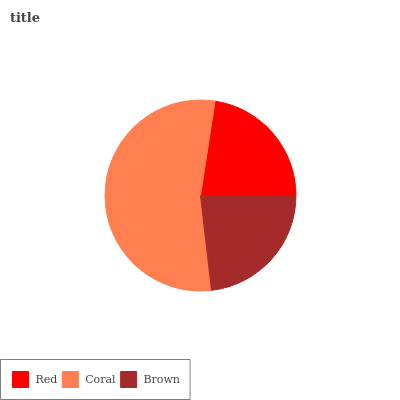Is Red the minimum?
Answer yes or no. Yes. Is Coral the maximum?
Answer yes or no. Yes. Is Brown the minimum?
Answer yes or no. No. Is Brown the maximum?
Answer yes or no. No. Is Coral greater than Brown?
Answer yes or no. Yes. Is Brown less than Coral?
Answer yes or no. Yes. Is Brown greater than Coral?
Answer yes or no. No. Is Coral less than Brown?
Answer yes or no. No. Is Brown the high median?
Answer yes or no. Yes. Is Brown the low median?
Answer yes or no. Yes. Is Red the high median?
Answer yes or no. No. Is Red the low median?
Answer yes or no. No. 